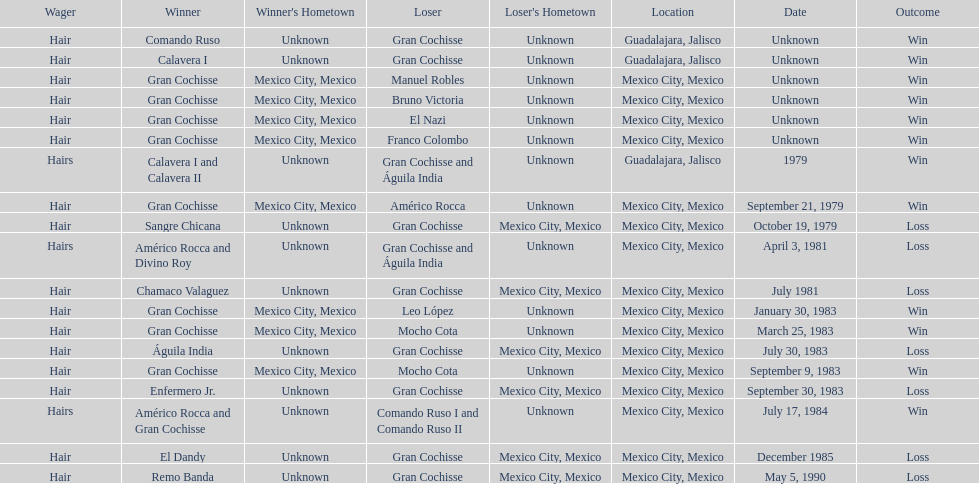What was the number of losses gran cochisse had against el dandy? 1. 